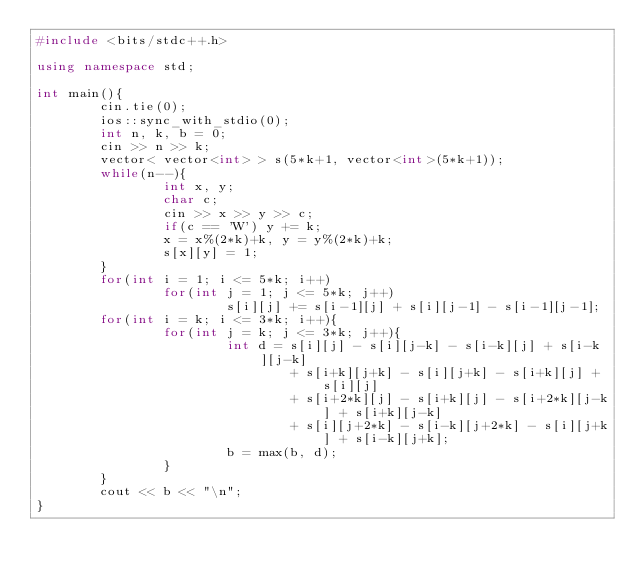<code> <loc_0><loc_0><loc_500><loc_500><_C++_>#include <bits/stdc++.h>

using namespace std;

int main(){
        cin.tie(0);
        ios::sync_with_stdio(0);
        int n, k, b = 0;
        cin >> n >> k;
        vector< vector<int> > s(5*k+1, vector<int>(5*k+1));
        while(n--){
                int x, y;
                char c;
                cin >> x >> y >> c;
                if(c == 'W') y += k;
                x = x%(2*k)+k, y = y%(2*k)+k;
                s[x][y] = 1;
        }
        for(int i = 1; i <= 5*k; i++)
                for(int j = 1; j <= 5*k; j++)
                        s[i][j] += s[i-1][j] + s[i][j-1] - s[i-1][j-1];
        for(int i = k; i <= 3*k; i++){
                for(int j = k; j <= 3*k; j++){
                        int d = s[i][j] - s[i][j-k] - s[i-k][j] + s[i-k][j-k]
                                + s[i+k][j+k] - s[i][j+k] - s[i+k][j] + s[i][j]
                                + s[i+2*k][j] - s[i+k][j] - s[i+2*k][j-k] + s[i+k][j-k]
                                + s[i][j+2*k] - s[i-k][j+2*k] - s[i][j+k] + s[i-k][j+k];
                        b = max(b, d);
                }
        }
        cout << b << "\n";
}
</code> 